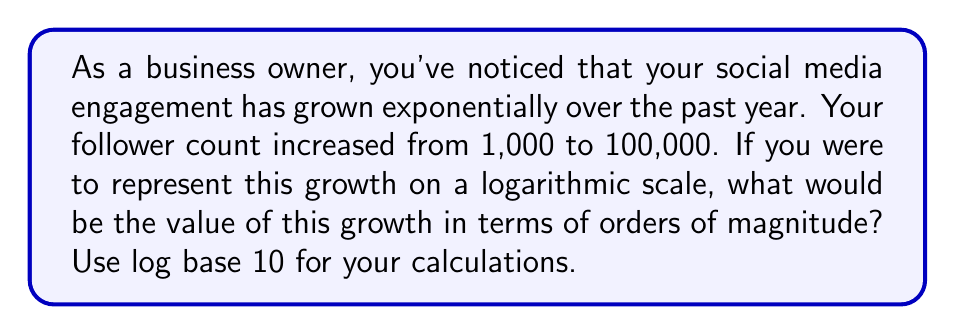What is the answer to this math problem? To solve this problem, we need to use the properties of logarithms, specifically the logarithm of a ratio. We're looking for the order of magnitude of growth, which is represented by the logarithm of the ratio of the final value to the initial value.

Let's break it down step by step:

1) We start with the formula for calculating the order of magnitude:
   $$ \text{Order of Magnitude} = \log_{10}\left(\frac{\text{Final Value}}{\text{Initial Value}}\right) $$

2) Plug in the values:
   $$ \log_{10}\left(\frac{100,000}{1,000}\right) $$

3) Simplify the fraction inside the logarithm:
   $$ \log_{10}(100) $$

4) Recall that $\log_{10}(100) = 2$ because $10^2 = 100$

Therefore, the growth in follower count represents an increase of 2 orders of magnitude on a logarithmic scale.

This logarithmic representation is useful in social media analytics as it allows for easy comparison of growth across different scales and time periods.
Answer: 2 orders of magnitude 